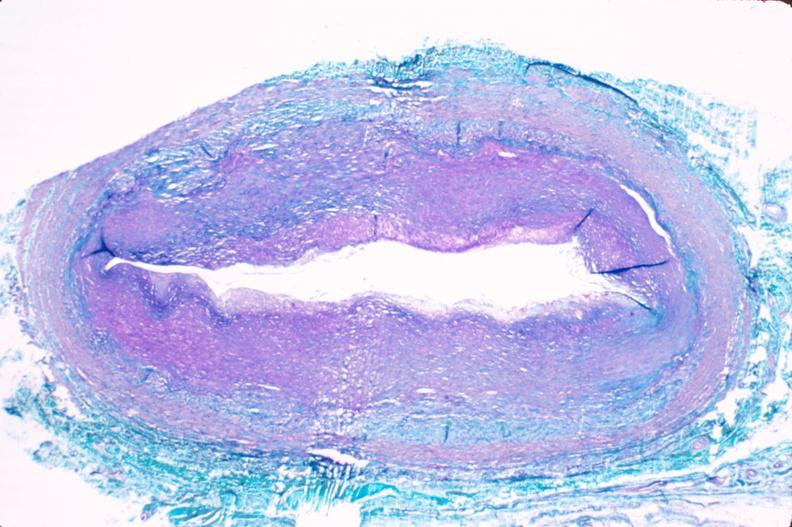does this image show saphenous vein graft sclerosis?
Answer the question using a single word or phrase. Yes 